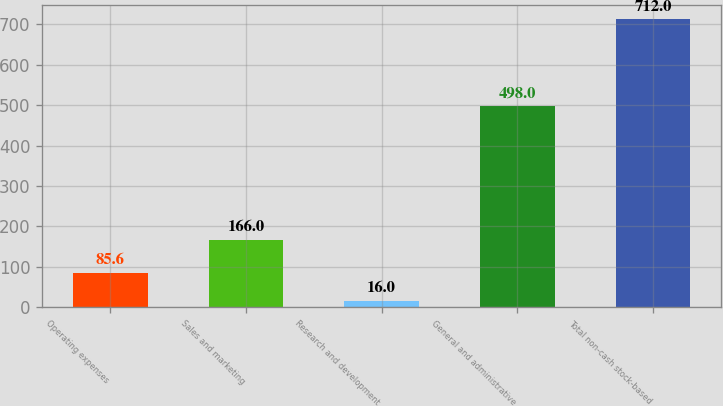Convert chart to OTSL. <chart><loc_0><loc_0><loc_500><loc_500><bar_chart><fcel>Operating expenses<fcel>Sales and marketing<fcel>Research and development<fcel>General and administrative<fcel>Total non-cash stock-based<nl><fcel>85.6<fcel>166<fcel>16<fcel>498<fcel>712<nl></chart> 